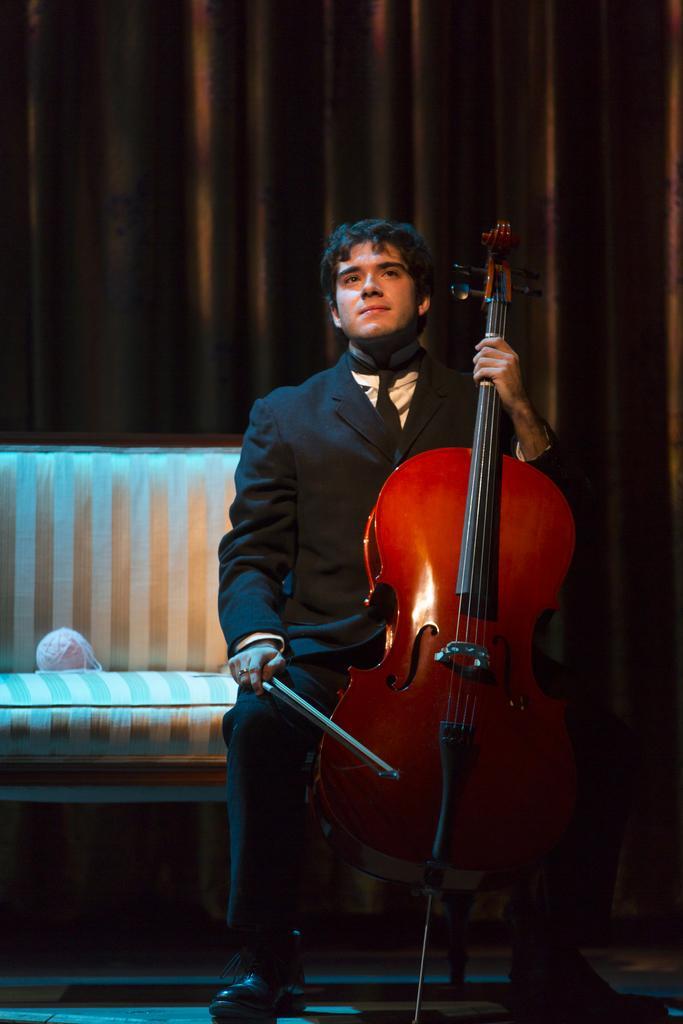In one or two sentences, can you explain what this image depicts? In this picture there is a man sitting on the chair. He is holding a stick and a violin in his hands. There is a brown curtain at the background. There is an object on the chair. 